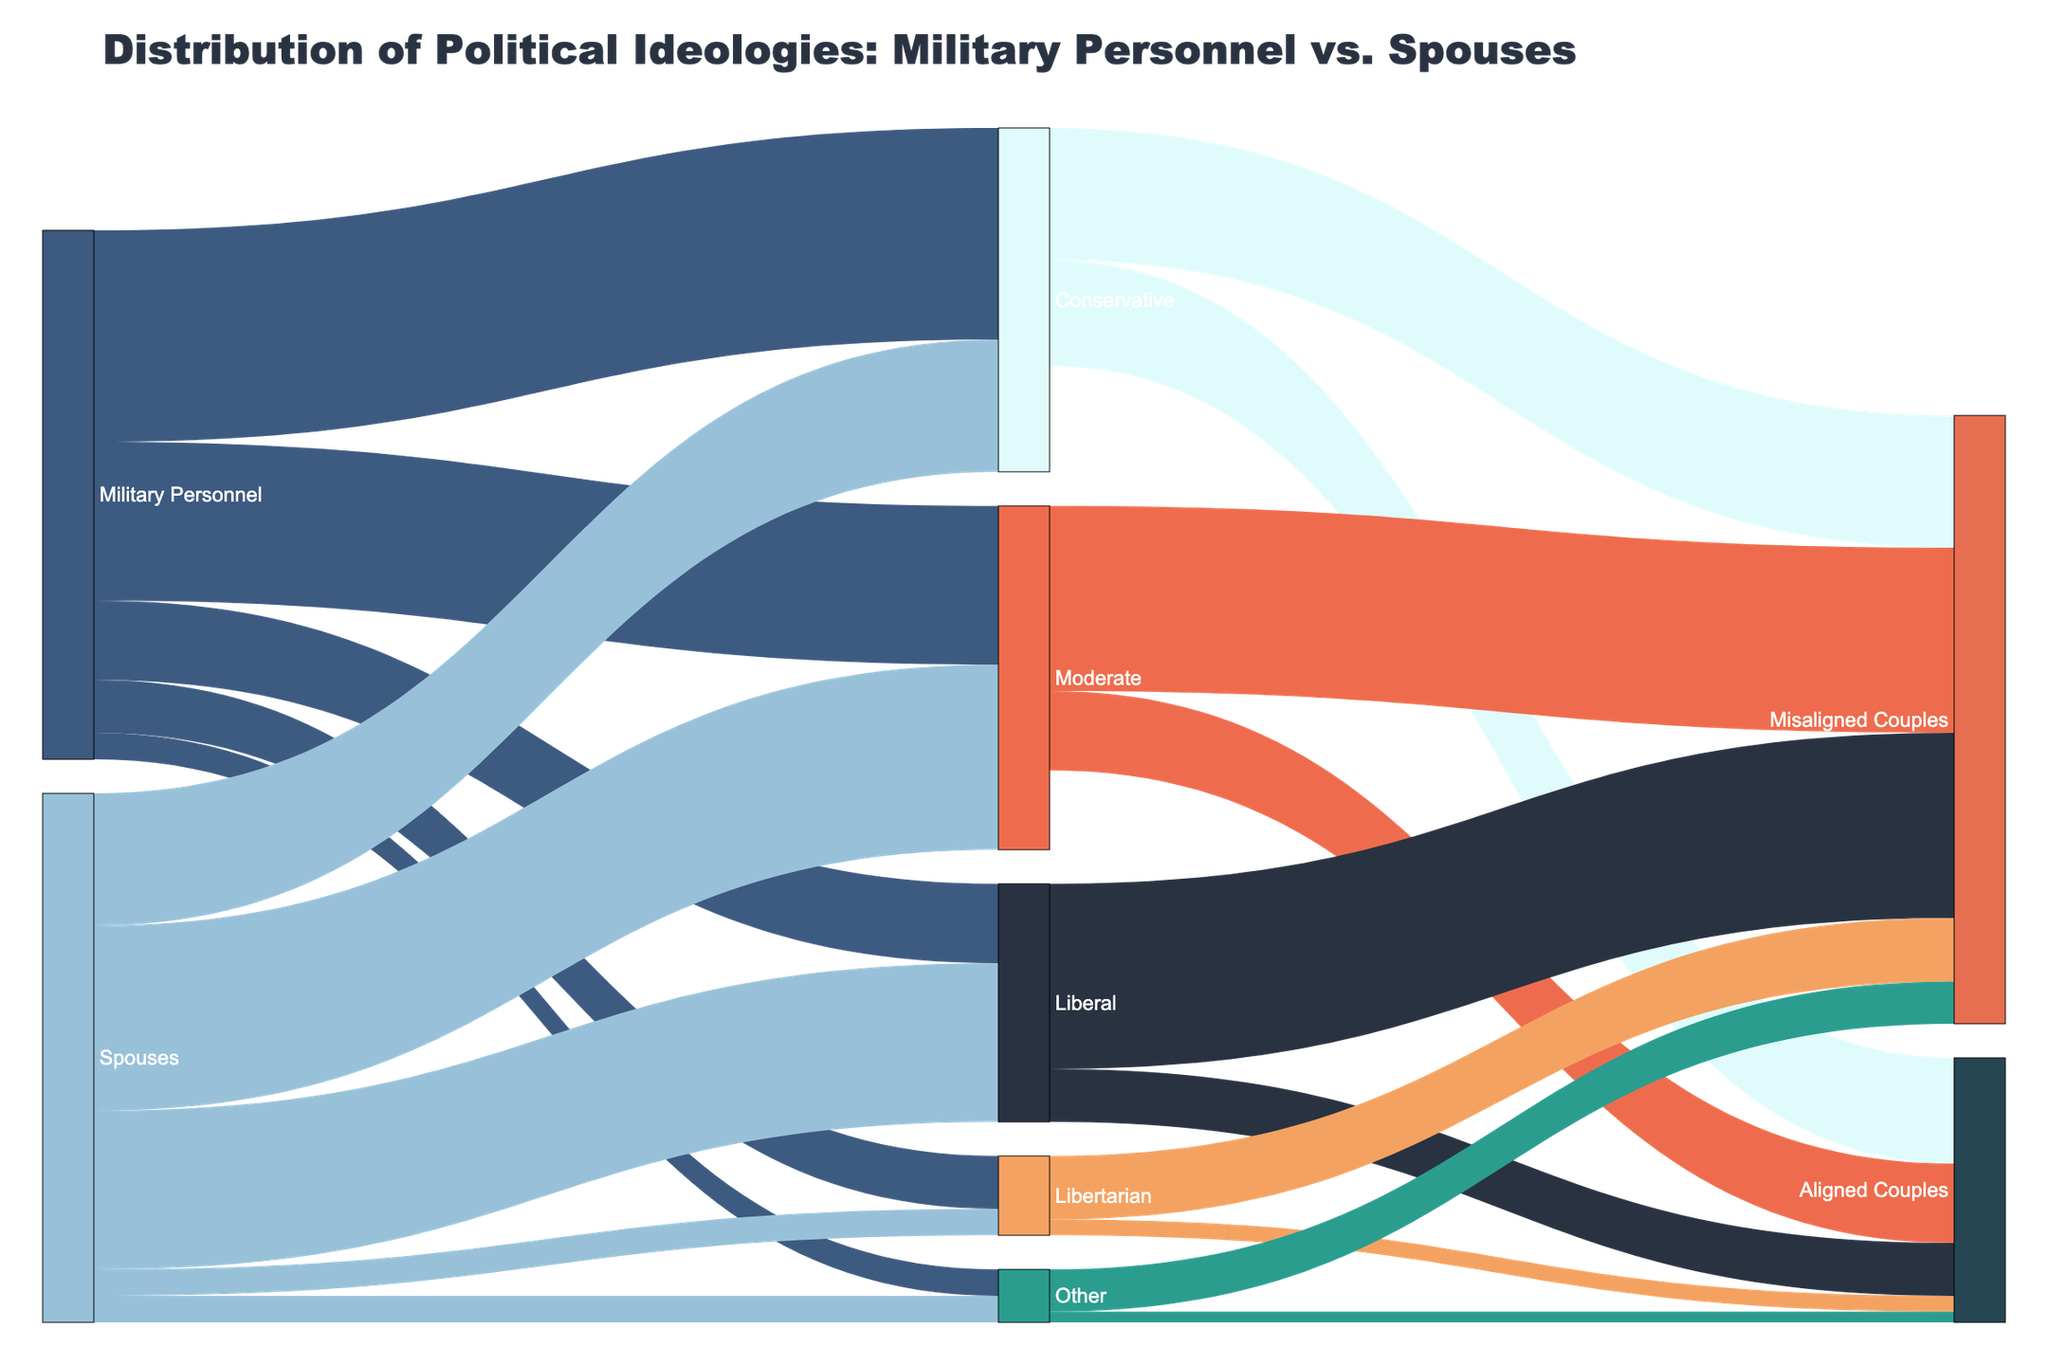What's the most common political ideology among military personnel? From the figure, we see that the largest flow originating from "Military Personnel" leads to "Conservative" with a value of 40, making it the most common ideology.
Answer: Conservative What's the least common political ideology among military personnel? The figure shows the smallest flow stemming from "Military Personnel" goes to "Other" with a value of 5, indicating it is the least common ideology.
Answer: Other Which group has more individuals identifying as Liberal, military personnel or spouses? By examining the flows, we can see that "Military Personnel" have a value of 15 identifying as Liberal, while "Spouses" have a higher value of 30 for Liberal. Thus, spouses have more individuals identifying as Liberal.
Answer: Spouses How many couples are ideologically aligned as Conservatives? From the flows exiting "Conservative," we notice that the flow to "Aligned Couples" has a value of 20. This indicates there are 20 Conservative-aligned couples.
Answer: 20 What's the total number of Misaligned couples? The combined values of flows going to "Misaligned Couples" are: 25 (Conservative) + 35 (Moderate) + 35 (Liberal) + 12 (Libertarian) + 8 (Other) = 115. Therefore, there are 115 Misaligned couples in total.
Answer: 115 How many military personnel and their spouses identify as Libertarian together? Adding the values from both groups "Military Personnel" and "Spouses" identifying as Libertarian: 10 (Military Personnel) + 5 (Spouses) = 15. Hence, 15 individuals identify as Libertarian in total.
Answer: 15 Which ideology has the highest combined flow to Misaligned Couples? By comparing the flows to "Misaligned Couples" for each ideology, "Liberal" has the highest combined value at 35.
Answer: Liberal What is the total number of individuals identifying as Moderate across both military personnel and spouses? Summing the values for "Moderate" in both groups: 30 (Military Personnel) + 35 (Spouses) = 65. Therefore, there are 65 individuals identifying as Moderate.
Answer: 65 Are there more Conservative-aligned or Moderate-aligned couples? By comparing the aligned values: "Conservative" has 20 aligned couples, and "Moderate" has 15 aligned couples. Thus, there are more Conservative-aligned couples.
Answer: Conservative-aligned couples 